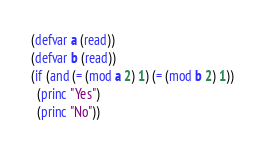Convert code to text. <code><loc_0><loc_0><loc_500><loc_500><_Lisp_>(defvar a (read))
(defvar b (read))
(if (and (= (mod a 2) 1) (= (mod b 2) 1))
  (princ "Yes")
  (princ "No"))</code> 